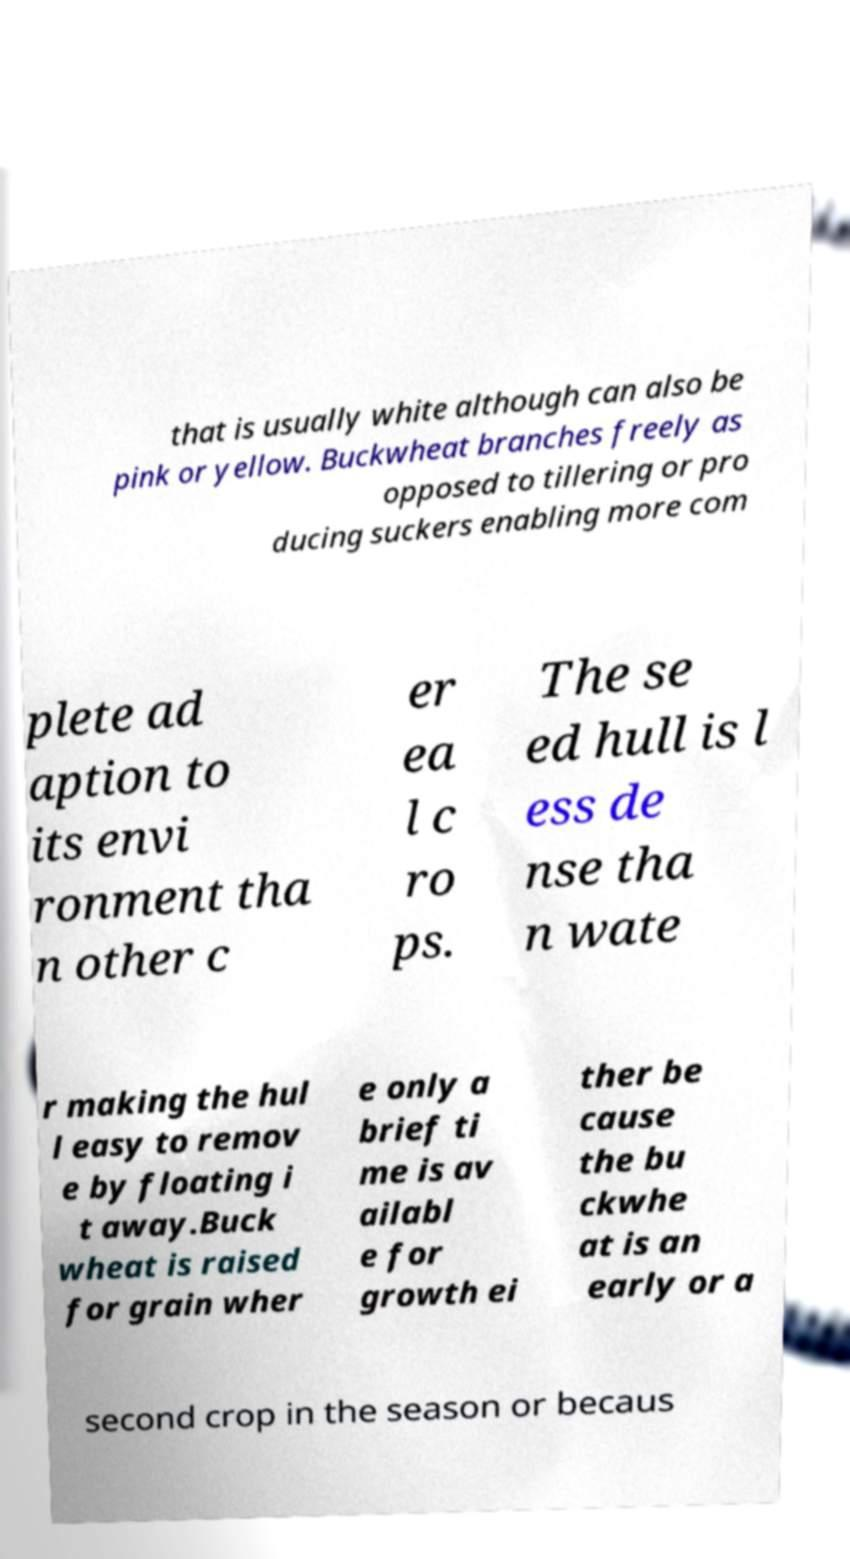Please identify and transcribe the text found in this image. that is usually white although can also be pink or yellow. Buckwheat branches freely as opposed to tillering or pro ducing suckers enabling more com plete ad aption to its envi ronment tha n other c er ea l c ro ps. The se ed hull is l ess de nse tha n wate r making the hul l easy to remov e by floating i t away.Buck wheat is raised for grain wher e only a brief ti me is av ailabl e for growth ei ther be cause the bu ckwhe at is an early or a second crop in the season or becaus 